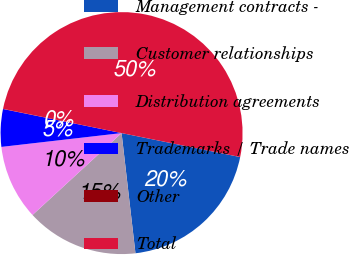<chart> <loc_0><loc_0><loc_500><loc_500><pie_chart><fcel>Management contracts -<fcel>Customer relationships<fcel>Distribution agreements<fcel>Trademarks / Trade names<fcel>Other<fcel>Total<nl><fcel>20.0%<fcel>15.0%<fcel>10.01%<fcel>5.01%<fcel>0.02%<fcel>49.97%<nl></chart> 